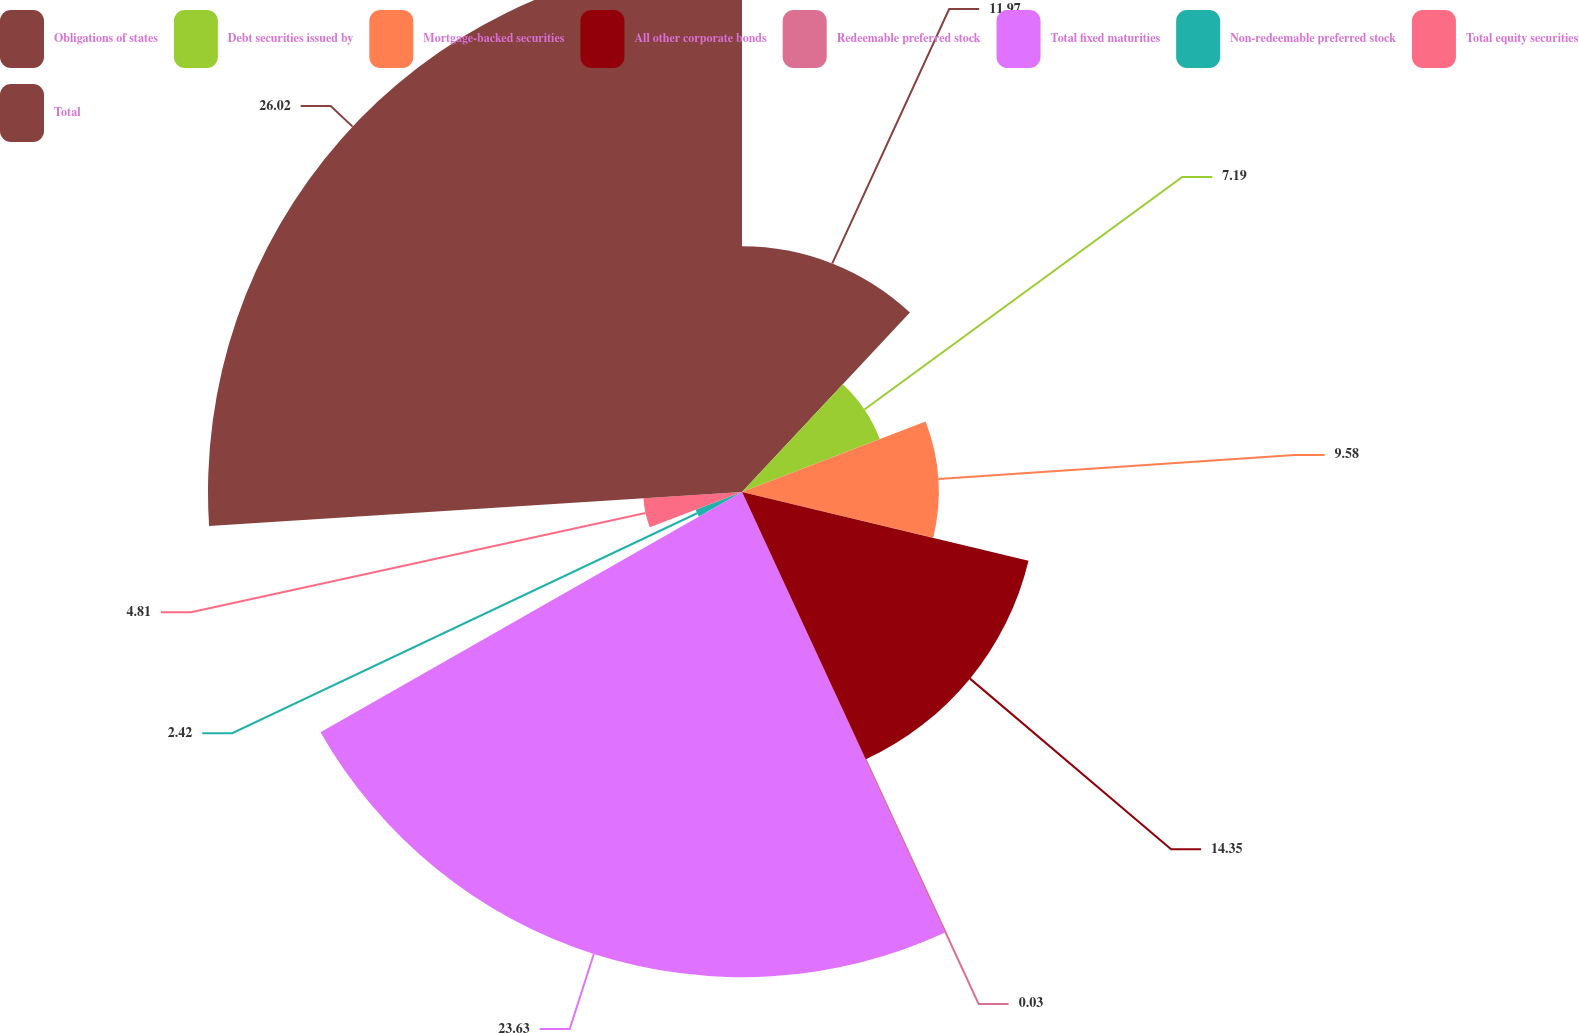Convert chart. <chart><loc_0><loc_0><loc_500><loc_500><pie_chart><fcel>Obligations of states<fcel>Debt securities issued by<fcel>Mortgage-backed securities<fcel>All other corporate bonds<fcel>Redeemable preferred stock<fcel>Total fixed maturities<fcel>Non-redeemable preferred stock<fcel>Total equity securities<fcel>Total<nl><fcel>11.97%<fcel>7.19%<fcel>9.58%<fcel>14.35%<fcel>0.03%<fcel>23.63%<fcel>2.42%<fcel>4.81%<fcel>26.01%<nl></chart> 